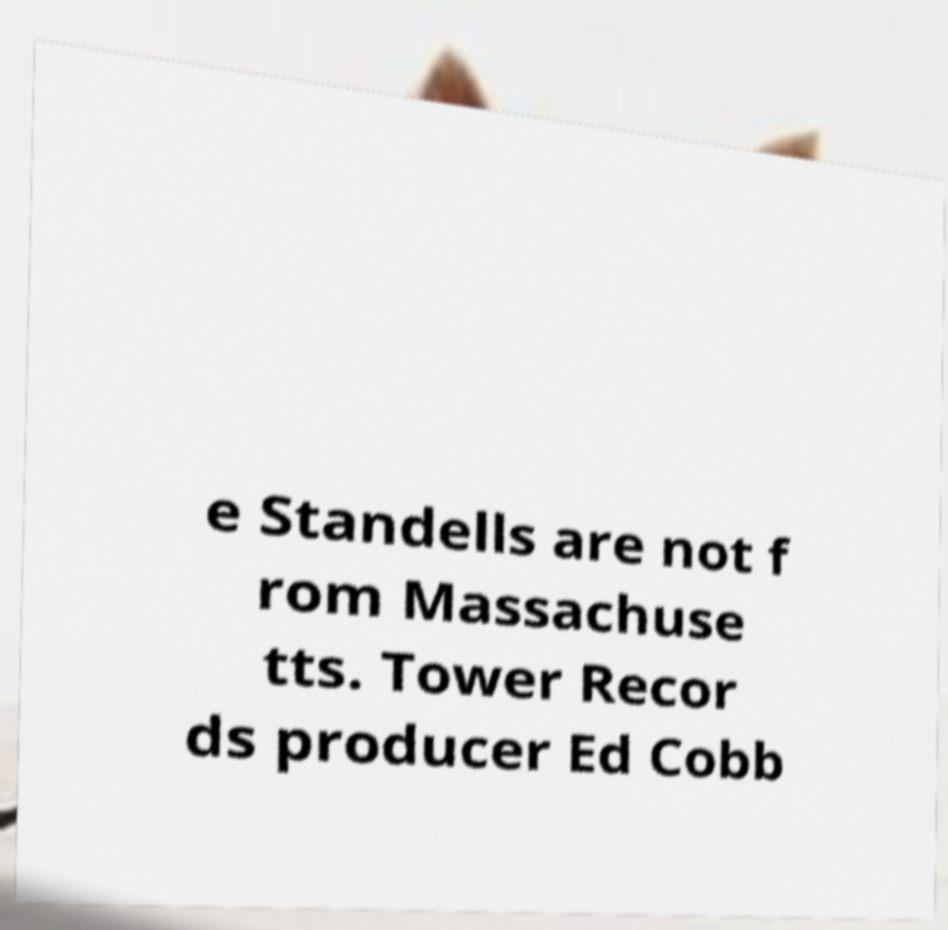What messages or text are displayed in this image? I need them in a readable, typed format. e Standells are not f rom Massachuse tts. Tower Recor ds producer Ed Cobb 